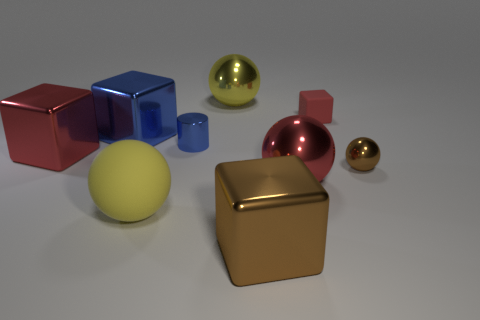Subtract all balls. How many objects are left? 5 Add 9 large yellow metal cubes. How many large yellow metal cubes exist? 9 Subtract 0 purple balls. How many objects are left? 9 Subtract all small shiny cylinders. Subtract all red objects. How many objects are left? 5 Add 7 big rubber spheres. How many big rubber spheres are left? 8 